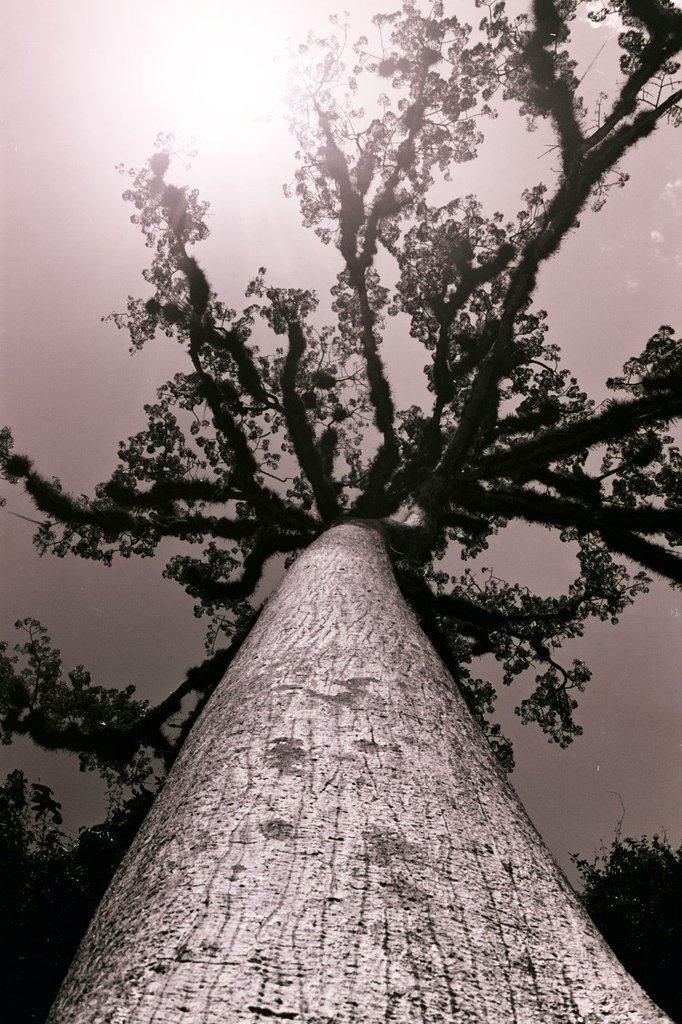What is the main subject in the middle of the image? There is a tree in the middle of the image. What can be seen at the top of the image? The sky is visible at the top of the image. How is the image presented in terms of color? The image is in black and white color. Is there a flag flying in the image? There is no flag present in the image. Can you see someone swimming in the image? There is no swimming activity depicted in the image. 